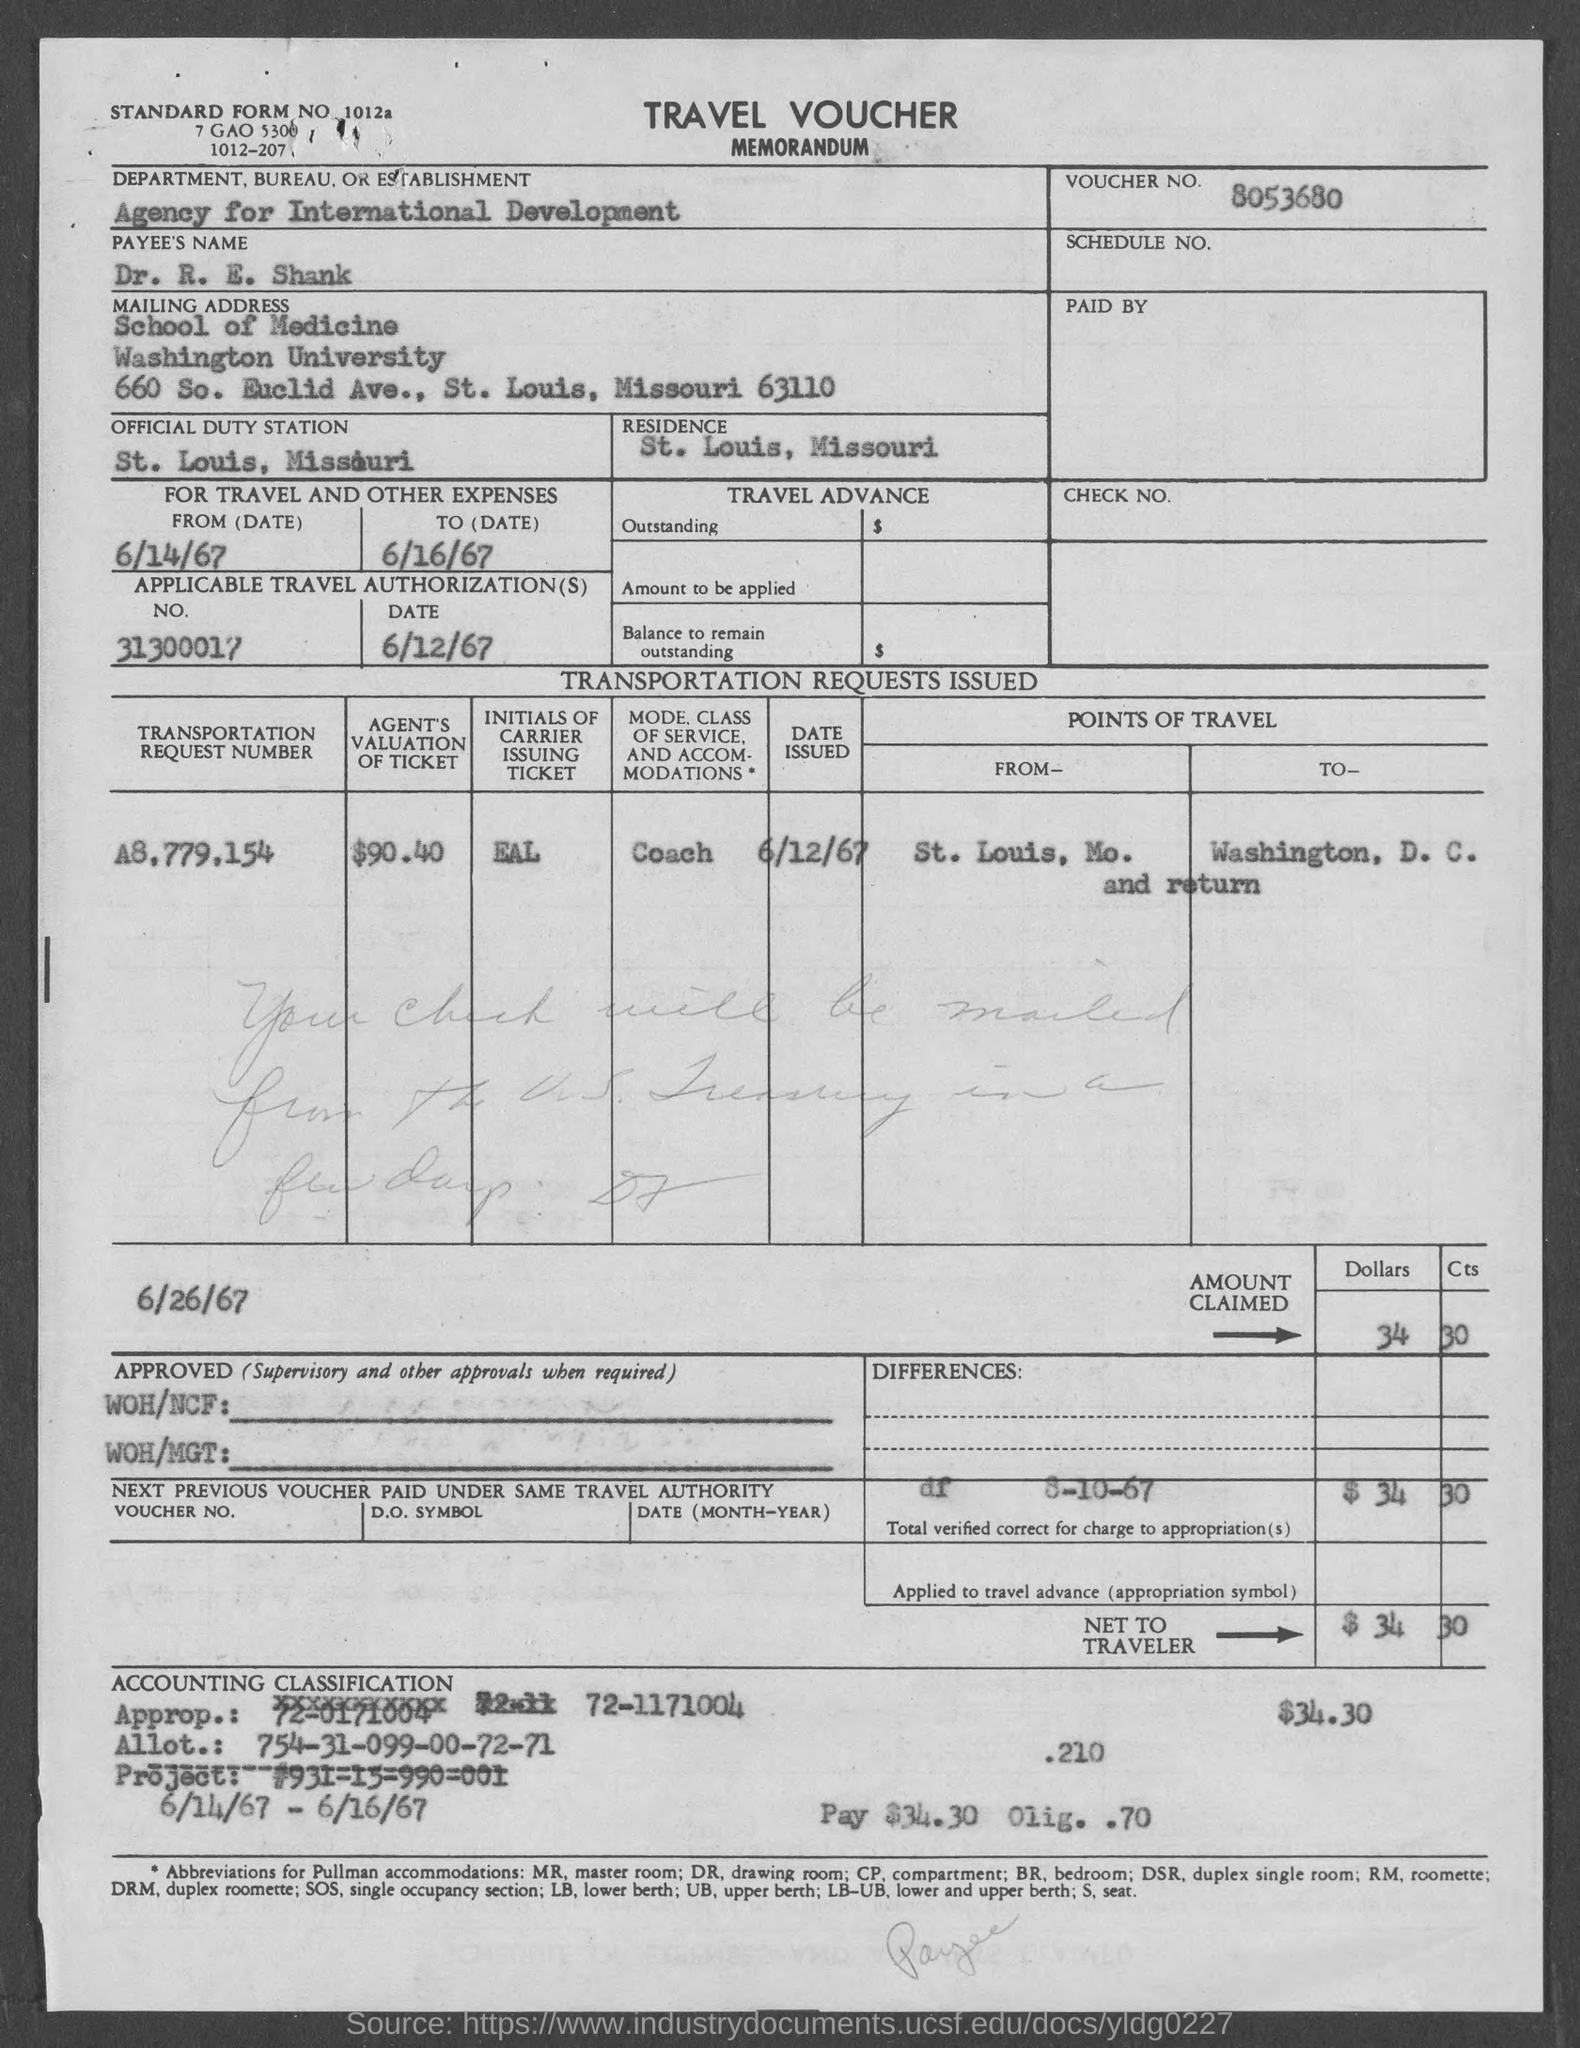Outline some significant characteristics in this image. The Department, Bureau, or Establishment mentioned in the travel voucher is the Agency for International Development. The payee's name listed in the travel voucher is "Dr. R. E. Shank. The applicable travel authorization date, as indicated in the travel voucher, is 6/12/67. The voucher number provided in the memorandum is 8053680... Dr. R. E. Shank's official duty station is St. Louis, Missouri. 